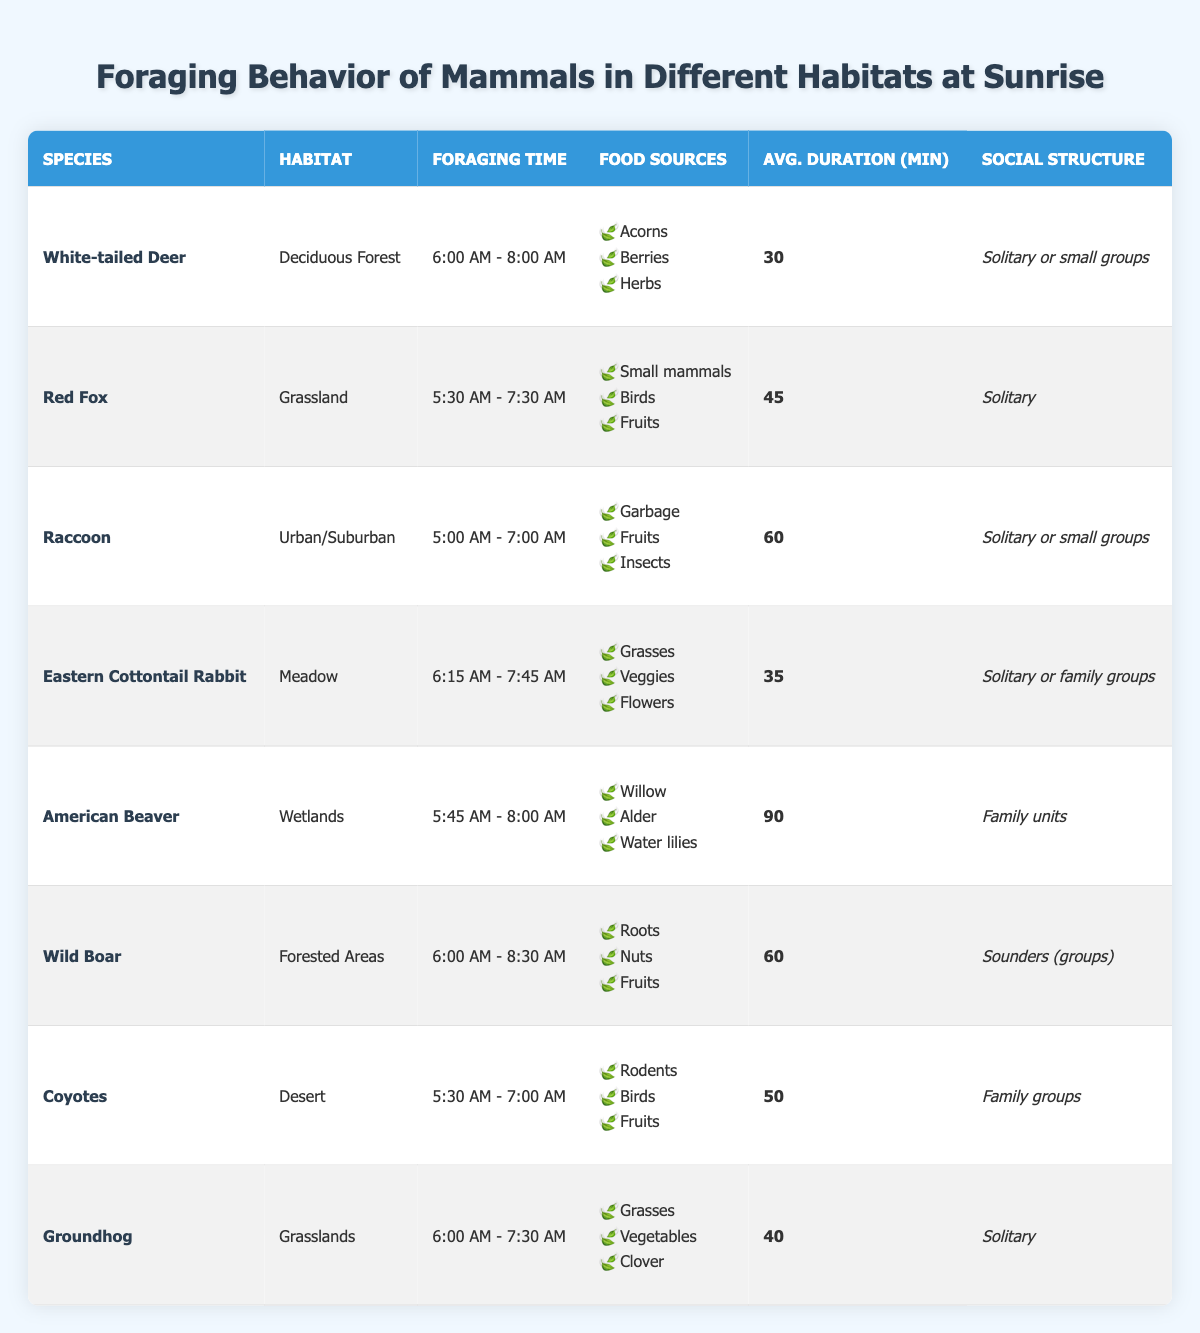What is the foraging time for the Red Fox? According to the table, the foraging time for the Red Fox is listed as "5:30 AM - 7:30 AM".
Answer: 5:30 AM - 7:30 AM How many food sources do Eastern Cottontail Rabbits have? The table shows that Eastern Cottontail Rabbits have three food sources: Grasses, Veggies, and Flowers.
Answer: 3 Which species forages the longest on average? The American Beaver has the longest average foraging duration listed in the table, which is 90 minutes.
Answer: American Beaver Is the social structure of the Raccoon solitary or in groups? The table indicates that Raccoons can be solitary or in small groups, confirming that both social structures apply.
Answer: Yes What is the average foraging duration of species that forage in Urban/Suburban habitats? There is only one species that forages in Urban/Suburban habitats, the Raccoon, which has an average duration of 60 minutes. Therefore, the average is also 60 minutes.
Answer: 60 Which two species foraging times overlap between 6:00 AM and 7:30 AM? The White-tailed Deer (6:00 AM - 8:00 AM) and Groundhog (6:00 AM - 7:30 AM) have overlapping foraging times during that period.
Answer: White-tailed Deer and Groundhog What is the total average foraging duration of all species listed? To find the total average, we add up all the average durations (30 + 45 + 60 + 35 + 90 + 60 + 50 + 40), which totals 410 minutes. Then we divide by the number of species, which is 8, giving us an average of 51.25 minutes (or approximately 51 minutes when rounded).
Answer: 51 Do any of the species listed have a social structure of family units? Yes, the American Beaver is listed with a social structure of family units.
Answer: Yes Which habitat has the largest variety of food sources? The Raccoon in Urban/Suburban habitat mentions three food sources: Garbage, Fruits, and Insects. The other habitats, by comparison, have varying food sources, but none listed exceed three in this table. Hence, Urban/Suburban has the largest variety.
Answer: Urban/Suburban What species typically forages in family groups? According to the table, Coyotes and American Beavers typically forage in family groups.
Answer: Coyotes and American Beavers 